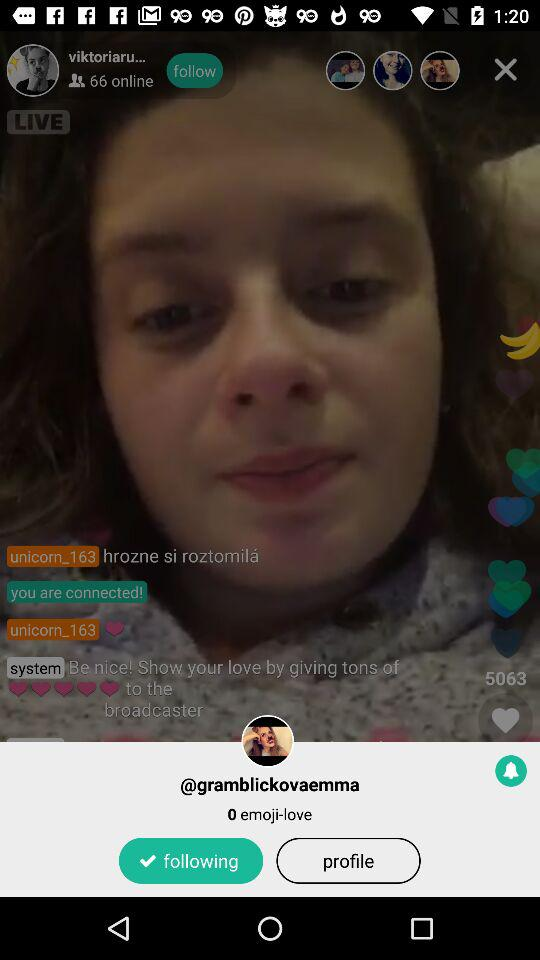What is the user name?
When the provided information is insufficient, respond with <no answer>. <no answer> 